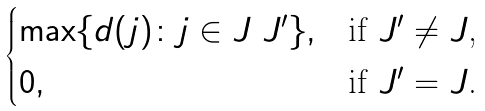<formula> <loc_0><loc_0><loc_500><loc_500>\begin{cases} \max \{ d ( j ) \colon j \in J \ J ^ { \prime } \} , & \text {if $J^{\prime}\neq J$,} \\ 0 , & \text {if $J^{\prime}= J$.} \end{cases}</formula> 